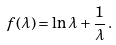<formula> <loc_0><loc_0><loc_500><loc_500>f ( \lambda ) = \ln \lambda + \frac { 1 } { \lambda } \, .</formula> 